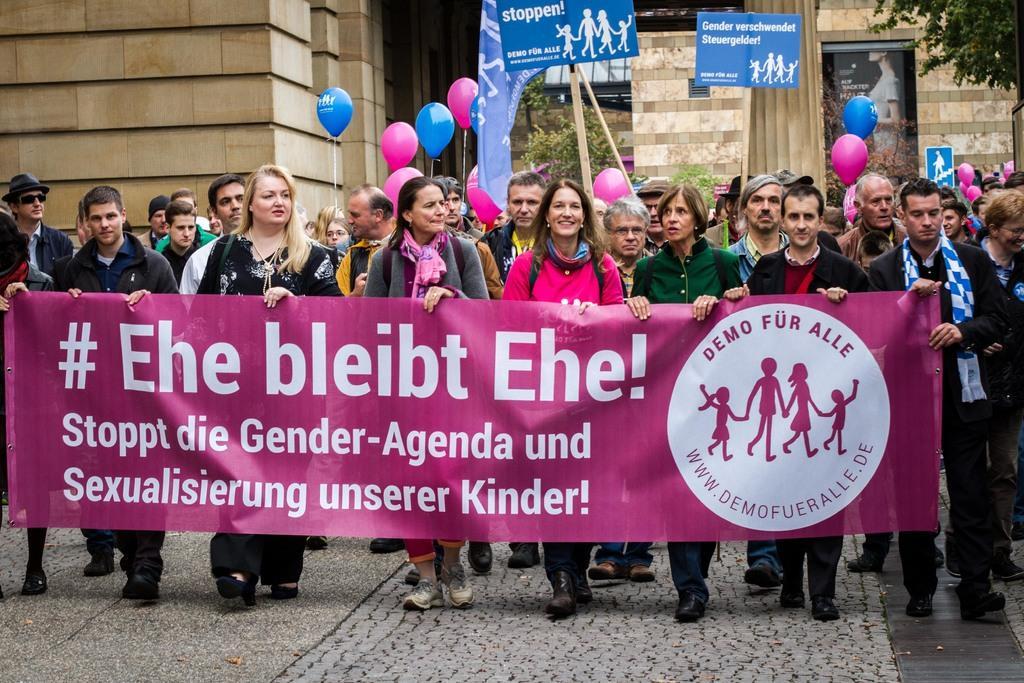Can you describe this image briefly? This picture is clicked outside. In the foreground we can see the group of people standing and holding a banner and we can see the text and the depictions of group of people on the banner. In the center we can see the group of people seems to be walking on the ground and we can see the balloons and the text and the depictions of group of people on the posters and on the flag. In the background we can see the building, curtain, tree, plants and an object which seems to be the wall mounted poster containing the text and a depiction of a person. 